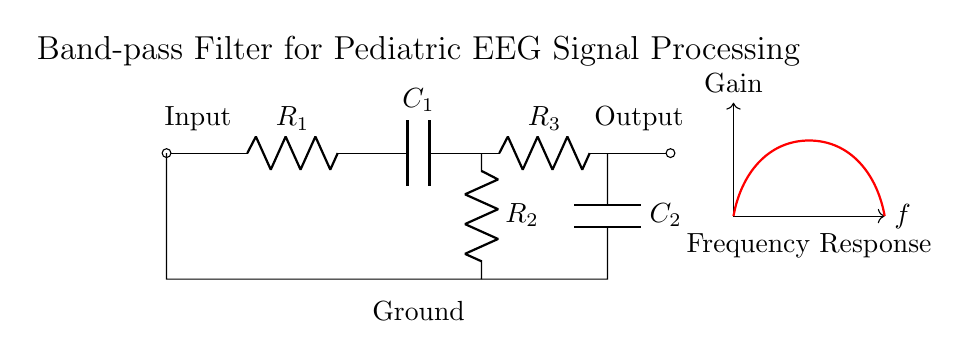What type of filter is this circuit? This circuit is a band-pass filter, as it is designed to allow frequencies within a specific range to pass while attenuating frequencies outside of that range. This is indicated by the combination of high-pass and low-pass sections created by the capacitors and resistors.
Answer: Band-pass filter What components are used in the high-pass section? The high-pass section comprises a capacitor and a resistor, specifically labeled as Capacitor one and Resistor two in the circuit. This combination allows high frequencies to pass while blocking low frequencies.
Answer: Capacitor one, Resistor two How many resistors are present in this circuit? Upon inspecting the diagram, there are a total of three resistors shown, each identified and labeled in the circuit: Resistor one, Resistor two, and Resistor three.
Answer: Three What is the function of Capacitor two in this circuit? Capacitor two is part of the low-pass section and serves to block high frequency signals while allowing low frequencies to pass through to the output. This is critical for defining the cutoff frequency of the band-pass filter.
Answer: Blocks high frequencies What is the ground reference point in the circuit? The ground reference point is indicated at the bottom center of the circuit where the connections of Resistor two and Capacitor one converge, representing a common return path in the circuit. This is important for establishing a reference level for voltage measurements.
Answer: Ground What would happen if the values of Resistor three were increased? Increasing the value of Resistor three would lower the cutoff frequency of the low-pass filter section. This would allow a narrower range of high-frequency signals to be passed, affecting the overall frequency response of the band-pass filter.
Answer: Lower cutoff frequency What is the significance of the frequency response curve in this circuit? The frequency response curve visually represents how the gain of the circuit varies with frequency, confirming that the circuit allows specific frequency ranges to pass while attenuating others. It demonstrates the filter's behavior and effectiveness in EEG signal processing.
Answer: Gain vs. frequency 